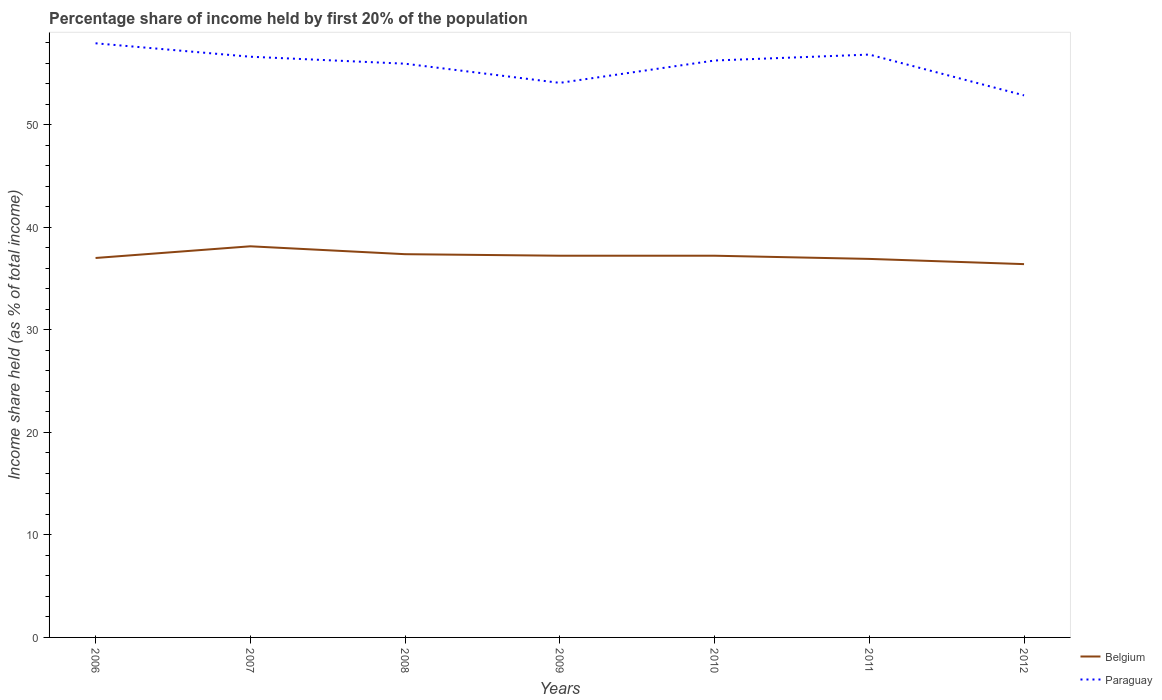How many different coloured lines are there?
Your answer should be compact. 2. Does the line corresponding to Paraguay intersect with the line corresponding to Belgium?
Offer a very short reply. No. Is the number of lines equal to the number of legend labels?
Offer a terse response. Yes. Across all years, what is the maximum share of income held by first 20% of the population in Paraguay?
Your answer should be very brief. 52.87. What is the total share of income held by first 20% of the population in Paraguay in the graph?
Your answer should be compact. 1.68. What is the difference between the highest and the second highest share of income held by first 20% of the population in Belgium?
Provide a short and direct response. 1.74. Is the share of income held by first 20% of the population in Belgium strictly greater than the share of income held by first 20% of the population in Paraguay over the years?
Your answer should be very brief. Yes. What is the difference between two consecutive major ticks on the Y-axis?
Give a very brief answer. 10. Does the graph contain grids?
Give a very brief answer. No. How many legend labels are there?
Keep it short and to the point. 2. How are the legend labels stacked?
Give a very brief answer. Vertical. What is the title of the graph?
Keep it short and to the point. Percentage share of income held by first 20% of the population. Does "Sub-Saharan Africa (developing only)" appear as one of the legend labels in the graph?
Your response must be concise. No. What is the label or title of the Y-axis?
Your response must be concise. Income share held (as % of total income). What is the Income share held (as % of total income) of Belgium in 2006?
Offer a terse response. 37.01. What is the Income share held (as % of total income) in Paraguay in 2006?
Give a very brief answer. 57.95. What is the Income share held (as % of total income) in Belgium in 2007?
Your answer should be very brief. 38.15. What is the Income share held (as % of total income) in Paraguay in 2007?
Your response must be concise. 56.64. What is the Income share held (as % of total income) of Belgium in 2008?
Provide a succinct answer. 37.38. What is the Income share held (as % of total income) of Paraguay in 2008?
Make the answer very short. 55.96. What is the Income share held (as % of total income) in Belgium in 2009?
Keep it short and to the point. 37.23. What is the Income share held (as % of total income) in Paraguay in 2009?
Provide a short and direct response. 54.09. What is the Income share held (as % of total income) of Belgium in 2010?
Your answer should be compact. 37.23. What is the Income share held (as % of total income) of Paraguay in 2010?
Your response must be concise. 56.27. What is the Income share held (as % of total income) of Belgium in 2011?
Give a very brief answer. 36.92. What is the Income share held (as % of total income) of Paraguay in 2011?
Give a very brief answer. 56.85. What is the Income share held (as % of total income) of Belgium in 2012?
Make the answer very short. 36.41. What is the Income share held (as % of total income) in Paraguay in 2012?
Keep it short and to the point. 52.87. Across all years, what is the maximum Income share held (as % of total income) of Belgium?
Your answer should be very brief. 38.15. Across all years, what is the maximum Income share held (as % of total income) in Paraguay?
Ensure brevity in your answer.  57.95. Across all years, what is the minimum Income share held (as % of total income) in Belgium?
Ensure brevity in your answer.  36.41. Across all years, what is the minimum Income share held (as % of total income) in Paraguay?
Ensure brevity in your answer.  52.87. What is the total Income share held (as % of total income) of Belgium in the graph?
Offer a terse response. 260.33. What is the total Income share held (as % of total income) in Paraguay in the graph?
Give a very brief answer. 390.63. What is the difference between the Income share held (as % of total income) in Belgium in 2006 and that in 2007?
Ensure brevity in your answer.  -1.14. What is the difference between the Income share held (as % of total income) in Paraguay in 2006 and that in 2007?
Your response must be concise. 1.31. What is the difference between the Income share held (as % of total income) of Belgium in 2006 and that in 2008?
Provide a short and direct response. -0.37. What is the difference between the Income share held (as % of total income) in Paraguay in 2006 and that in 2008?
Provide a succinct answer. 1.99. What is the difference between the Income share held (as % of total income) of Belgium in 2006 and that in 2009?
Make the answer very short. -0.22. What is the difference between the Income share held (as % of total income) in Paraguay in 2006 and that in 2009?
Provide a short and direct response. 3.86. What is the difference between the Income share held (as % of total income) of Belgium in 2006 and that in 2010?
Ensure brevity in your answer.  -0.22. What is the difference between the Income share held (as % of total income) of Paraguay in 2006 and that in 2010?
Your response must be concise. 1.68. What is the difference between the Income share held (as % of total income) of Belgium in 2006 and that in 2011?
Your answer should be very brief. 0.09. What is the difference between the Income share held (as % of total income) in Paraguay in 2006 and that in 2011?
Offer a very short reply. 1.1. What is the difference between the Income share held (as % of total income) in Paraguay in 2006 and that in 2012?
Your answer should be very brief. 5.08. What is the difference between the Income share held (as % of total income) of Belgium in 2007 and that in 2008?
Offer a very short reply. 0.77. What is the difference between the Income share held (as % of total income) of Paraguay in 2007 and that in 2008?
Give a very brief answer. 0.68. What is the difference between the Income share held (as % of total income) of Belgium in 2007 and that in 2009?
Offer a very short reply. 0.92. What is the difference between the Income share held (as % of total income) in Paraguay in 2007 and that in 2009?
Make the answer very short. 2.55. What is the difference between the Income share held (as % of total income) in Belgium in 2007 and that in 2010?
Give a very brief answer. 0.92. What is the difference between the Income share held (as % of total income) of Paraguay in 2007 and that in 2010?
Your response must be concise. 0.37. What is the difference between the Income share held (as % of total income) in Belgium in 2007 and that in 2011?
Make the answer very short. 1.23. What is the difference between the Income share held (as % of total income) of Paraguay in 2007 and that in 2011?
Keep it short and to the point. -0.21. What is the difference between the Income share held (as % of total income) in Belgium in 2007 and that in 2012?
Your response must be concise. 1.74. What is the difference between the Income share held (as % of total income) in Paraguay in 2007 and that in 2012?
Make the answer very short. 3.77. What is the difference between the Income share held (as % of total income) in Belgium in 2008 and that in 2009?
Make the answer very short. 0.15. What is the difference between the Income share held (as % of total income) in Paraguay in 2008 and that in 2009?
Provide a short and direct response. 1.87. What is the difference between the Income share held (as % of total income) in Belgium in 2008 and that in 2010?
Your answer should be compact. 0.15. What is the difference between the Income share held (as % of total income) in Paraguay in 2008 and that in 2010?
Provide a succinct answer. -0.31. What is the difference between the Income share held (as % of total income) in Belgium in 2008 and that in 2011?
Your answer should be very brief. 0.46. What is the difference between the Income share held (as % of total income) of Paraguay in 2008 and that in 2011?
Offer a very short reply. -0.89. What is the difference between the Income share held (as % of total income) in Paraguay in 2008 and that in 2012?
Offer a very short reply. 3.09. What is the difference between the Income share held (as % of total income) in Paraguay in 2009 and that in 2010?
Provide a succinct answer. -2.18. What is the difference between the Income share held (as % of total income) of Belgium in 2009 and that in 2011?
Keep it short and to the point. 0.31. What is the difference between the Income share held (as % of total income) in Paraguay in 2009 and that in 2011?
Keep it short and to the point. -2.76. What is the difference between the Income share held (as % of total income) in Belgium in 2009 and that in 2012?
Provide a succinct answer. 0.82. What is the difference between the Income share held (as % of total income) of Paraguay in 2009 and that in 2012?
Make the answer very short. 1.22. What is the difference between the Income share held (as % of total income) in Belgium in 2010 and that in 2011?
Your response must be concise. 0.31. What is the difference between the Income share held (as % of total income) of Paraguay in 2010 and that in 2011?
Ensure brevity in your answer.  -0.58. What is the difference between the Income share held (as % of total income) of Belgium in 2010 and that in 2012?
Provide a succinct answer. 0.82. What is the difference between the Income share held (as % of total income) of Paraguay in 2010 and that in 2012?
Ensure brevity in your answer.  3.4. What is the difference between the Income share held (as % of total income) of Belgium in 2011 and that in 2012?
Give a very brief answer. 0.51. What is the difference between the Income share held (as % of total income) in Paraguay in 2011 and that in 2012?
Your answer should be very brief. 3.98. What is the difference between the Income share held (as % of total income) in Belgium in 2006 and the Income share held (as % of total income) in Paraguay in 2007?
Give a very brief answer. -19.63. What is the difference between the Income share held (as % of total income) in Belgium in 2006 and the Income share held (as % of total income) in Paraguay in 2008?
Ensure brevity in your answer.  -18.95. What is the difference between the Income share held (as % of total income) of Belgium in 2006 and the Income share held (as % of total income) of Paraguay in 2009?
Your answer should be compact. -17.08. What is the difference between the Income share held (as % of total income) in Belgium in 2006 and the Income share held (as % of total income) in Paraguay in 2010?
Make the answer very short. -19.26. What is the difference between the Income share held (as % of total income) in Belgium in 2006 and the Income share held (as % of total income) in Paraguay in 2011?
Your answer should be compact. -19.84. What is the difference between the Income share held (as % of total income) in Belgium in 2006 and the Income share held (as % of total income) in Paraguay in 2012?
Ensure brevity in your answer.  -15.86. What is the difference between the Income share held (as % of total income) of Belgium in 2007 and the Income share held (as % of total income) of Paraguay in 2008?
Make the answer very short. -17.81. What is the difference between the Income share held (as % of total income) of Belgium in 2007 and the Income share held (as % of total income) of Paraguay in 2009?
Your response must be concise. -15.94. What is the difference between the Income share held (as % of total income) of Belgium in 2007 and the Income share held (as % of total income) of Paraguay in 2010?
Keep it short and to the point. -18.12. What is the difference between the Income share held (as % of total income) in Belgium in 2007 and the Income share held (as % of total income) in Paraguay in 2011?
Provide a short and direct response. -18.7. What is the difference between the Income share held (as % of total income) in Belgium in 2007 and the Income share held (as % of total income) in Paraguay in 2012?
Provide a succinct answer. -14.72. What is the difference between the Income share held (as % of total income) in Belgium in 2008 and the Income share held (as % of total income) in Paraguay in 2009?
Provide a short and direct response. -16.71. What is the difference between the Income share held (as % of total income) of Belgium in 2008 and the Income share held (as % of total income) of Paraguay in 2010?
Keep it short and to the point. -18.89. What is the difference between the Income share held (as % of total income) in Belgium in 2008 and the Income share held (as % of total income) in Paraguay in 2011?
Make the answer very short. -19.47. What is the difference between the Income share held (as % of total income) of Belgium in 2008 and the Income share held (as % of total income) of Paraguay in 2012?
Your response must be concise. -15.49. What is the difference between the Income share held (as % of total income) in Belgium in 2009 and the Income share held (as % of total income) in Paraguay in 2010?
Offer a terse response. -19.04. What is the difference between the Income share held (as % of total income) of Belgium in 2009 and the Income share held (as % of total income) of Paraguay in 2011?
Your answer should be compact. -19.62. What is the difference between the Income share held (as % of total income) of Belgium in 2009 and the Income share held (as % of total income) of Paraguay in 2012?
Offer a very short reply. -15.64. What is the difference between the Income share held (as % of total income) of Belgium in 2010 and the Income share held (as % of total income) of Paraguay in 2011?
Ensure brevity in your answer.  -19.62. What is the difference between the Income share held (as % of total income) in Belgium in 2010 and the Income share held (as % of total income) in Paraguay in 2012?
Your response must be concise. -15.64. What is the difference between the Income share held (as % of total income) in Belgium in 2011 and the Income share held (as % of total income) in Paraguay in 2012?
Your response must be concise. -15.95. What is the average Income share held (as % of total income) of Belgium per year?
Offer a terse response. 37.19. What is the average Income share held (as % of total income) in Paraguay per year?
Keep it short and to the point. 55.8. In the year 2006, what is the difference between the Income share held (as % of total income) in Belgium and Income share held (as % of total income) in Paraguay?
Your answer should be very brief. -20.94. In the year 2007, what is the difference between the Income share held (as % of total income) in Belgium and Income share held (as % of total income) in Paraguay?
Your response must be concise. -18.49. In the year 2008, what is the difference between the Income share held (as % of total income) in Belgium and Income share held (as % of total income) in Paraguay?
Your answer should be compact. -18.58. In the year 2009, what is the difference between the Income share held (as % of total income) in Belgium and Income share held (as % of total income) in Paraguay?
Your answer should be compact. -16.86. In the year 2010, what is the difference between the Income share held (as % of total income) of Belgium and Income share held (as % of total income) of Paraguay?
Your answer should be compact. -19.04. In the year 2011, what is the difference between the Income share held (as % of total income) of Belgium and Income share held (as % of total income) of Paraguay?
Provide a succinct answer. -19.93. In the year 2012, what is the difference between the Income share held (as % of total income) of Belgium and Income share held (as % of total income) of Paraguay?
Give a very brief answer. -16.46. What is the ratio of the Income share held (as % of total income) in Belgium in 2006 to that in 2007?
Your answer should be very brief. 0.97. What is the ratio of the Income share held (as % of total income) of Paraguay in 2006 to that in 2007?
Provide a short and direct response. 1.02. What is the ratio of the Income share held (as % of total income) of Paraguay in 2006 to that in 2008?
Your answer should be compact. 1.04. What is the ratio of the Income share held (as % of total income) of Belgium in 2006 to that in 2009?
Ensure brevity in your answer.  0.99. What is the ratio of the Income share held (as % of total income) in Paraguay in 2006 to that in 2009?
Your response must be concise. 1.07. What is the ratio of the Income share held (as % of total income) of Belgium in 2006 to that in 2010?
Ensure brevity in your answer.  0.99. What is the ratio of the Income share held (as % of total income) of Paraguay in 2006 to that in 2010?
Offer a terse response. 1.03. What is the ratio of the Income share held (as % of total income) of Paraguay in 2006 to that in 2011?
Ensure brevity in your answer.  1.02. What is the ratio of the Income share held (as % of total income) in Belgium in 2006 to that in 2012?
Make the answer very short. 1.02. What is the ratio of the Income share held (as % of total income) in Paraguay in 2006 to that in 2012?
Offer a terse response. 1.1. What is the ratio of the Income share held (as % of total income) of Belgium in 2007 to that in 2008?
Make the answer very short. 1.02. What is the ratio of the Income share held (as % of total income) in Paraguay in 2007 to that in 2008?
Provide a short and direct response. 1.01. What is the ratio of the Income share held (as % of total income) in Belgium in 2007 to that in 2009?
Provide a short and direct response. 1.02. What is the ratio of the Income share held (as % of total income) in Paraguay in 2007 to that in 2009?
Your answer should be very brief. 1.05. What is the ratio of the Income share held (as % of total income) in Belgium in 2007 to that in 2010?
Make the answer very short. 1.02. What is the ratio of the Income share held (as % of total income) of Paraguay in 2007 to that in 2010?
Give a very brief answer. 1.01. What is the ratio of the Income share held (as % of total income) of Belgium in 2007 to that in 2011?
Your answer should be very brief. 1.03. What is the ratio of the Income share held (as % of total income) of Paraguay in 2007 to that in 2011?
Your answer should be very brief. 1. What is the ratio of the Income share held (as % of total income) of Belgium in 2007 to that in 2012?
Your response must be concise. 1.05. What is the ratio of the Income share held (as % of total income) of Paraguay in 2007 to that in 2012?
Provide a short and direct response. 1.07. What is the ratio of the Income share held (as % of total income) of Paraguay in 2008 to that in 2009?
Make the answer very short. 1.03. What is the ratio of the Income share held (as % of total income) of Belgium in 2008 to that in 2010?
Keep it short and to the point. 1. What is the ratio of the Income share held (as % of total income) of Paraguay in 2008 to that in 2010?
Offer a terse response. 0.99. What is the ratio of the Income share held (as % of total income) in Belgium in 2008 to that in 2011?
Keep it short and to the point. 1.01. What is the ratio of the Income share held (as % of total income) of Paraguay in 2008 to that in 2011?
Offer a very short reply. 0.98. What is the ratio of the Income share held (as % of total income) of Belgium in 2008 to that in 2012?
Ensure brevity in your answer.  1.03. What is the ratio of the Income share held (as % of total income) in Paraguay in 2008 to that in 2012?
Keep it short and to the point. 1.06. What is the ratio of the Income share held (as % of total income) in Paraguay in 2009 to that in 2010?
Your answer should be very brief. 0.96. What is the ratio of the Income share held (as % of total income) in Belgium in 2009 to that in 2011?
Give a very brief answer. 1.01. What is the ratio of the Income share held (as % of total income) of Paraguay in 2009 to that in 2011?
Your answer should be very brief. 0.95. What is the ratio of the Income share held (as % of total income) of Belgium in 2009 to that in 2012?
Ensure brevity in your answer.  1.02. What is the ratio of the Income share held (as % of total income) of Paraguay in 2009 to that in 2012?
Make the answer very short. 1.02. What is the ratio of the Income share held (as % of total income) in Belgium in 2010 to that in 2011?
Ensure brevity in your answer.  1.01. What is the ratio of the Income share held (as % of total income) of Belgium in 2010 to that in 2012?
Your response must be concise. 1.02. What is the ratio of the Income share held (as % of total income) in Paraguay in 2010 to that in 2012?
Your answer should be very brief. 1.06. What is the ratio of the Income share held (as % of total income) of Belgium in 2011 to that in 2012?
Your response must be concise. 1.01. What is the ratio of the Income share held (as % of total income) in Paraguay in 2011 to that in 2012?
Give a very brief answer. 1.08. What is the difference between the highest and the second highest Income share held (as % of total income) in Belgium?
Keep it short and to the point. 0.77. What is the difference between the highest and the lowest Income share held (as % of total income) of Belgium?
Give a very brief answer. 1.74. What is the difference between the highest and the lowest Income share held (as % of total income) of Paraguay?
Make the answer very short. 5.08. 